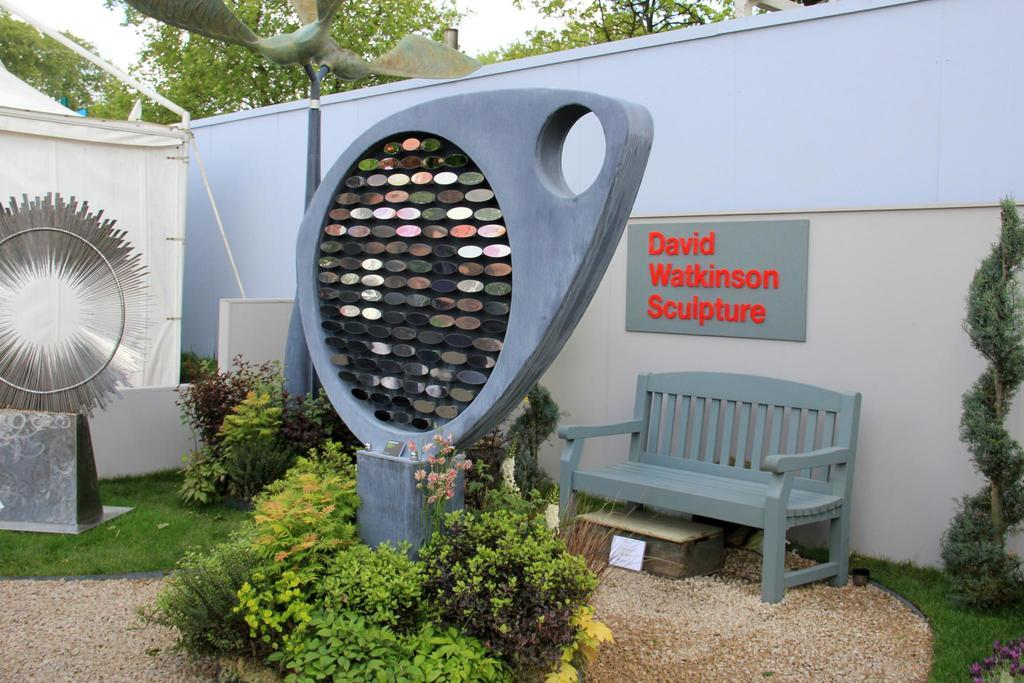What is located in the front of the image? In the front of the image, there is a wall, a tent, plants, grass, a bench, a box, information cards, and a board. Can you describe the objects in the front of the image? There are objects in the front of the image, including a bench, a box, and information cards. What type of vegetation can be seen in the front of the image? In the front of the image, there are plants and grass. What is visible in the background of the image? In the background of the image, there are trees and sky. What type of beast can be seen roaming around the tent in the image? There is no beast present in the image; it only features a tent, plants, grass, a bench, a box, information cards, and a board in the front, and trees and sky in the background. What surprise can be found hidden behind the wall in the image? There is no mention of a surprise hidden behind the wall in the image; it only shows a wall, a tent, plants, grass, a bench, a box, information cards, and a board in the front, and trees and sky in the background. 